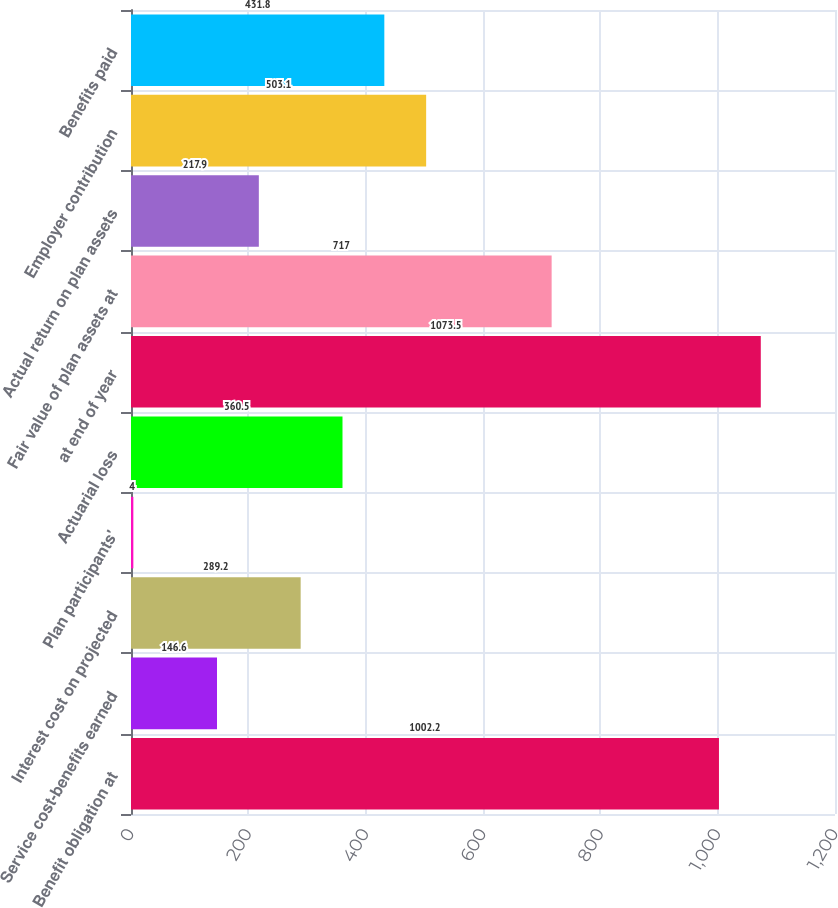<chart> <loc_0><loc_0><loc_500><loc_500><bar_chart><fcel>Benefit obligation at<fcel>Service cost-benefits earned<fcel>Interest cost on projected<fcel>Plan participants'<fcel>Actuarial loss<fcel>at end of year<fcel>Fair value of plan assets at<fcel>Actual return on plan assets<fcel>Employer contribution<fcel>Benefits paid<nl><fcel>1002.2<fcel>146.6<fcel>289.2<fcel>4<fcel>360.5<fcel>1073.5<fcel>717<fcel>217.9<fcel>503.1<fcel>431.8<nl></chart> 